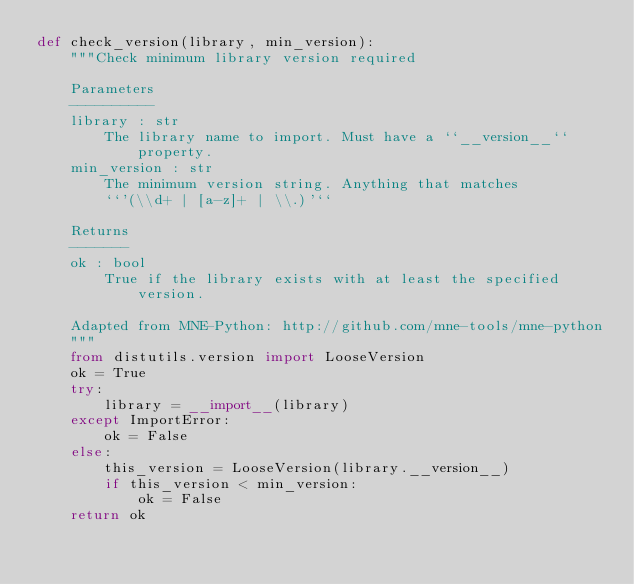<code> <loc_0><loc_0><loc_500><loc_500><_Python_>def check_version(library, min_version):
    """Check minimum library version required

    Parameters
    ----------
    library : str
        The library name to import. Must have a ``__version__`` property.
    min_version : str
        The minimum version string. Anything that matches
        ``'(\\d+ | [a-z]+ | \\.)'``

    Returns
    -------
    ok : bool
        True if the library exists with at least the specified version.

    Adapted from MNE-Python: http://github.com/mne-tools/mne-python
    """
    from distutils.version import LooseVersion
    ok = True
    try:
        library = __import__(library)
    except ImportError:
        ok = False
    else:
        this_version = LooseVersion(library.__version__)
        if this_version < min_version:
            ok = False
    return ok
</code> 